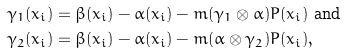<formula> <loc_0><loc_0><loc_500><loc_500>& \gamma _ { 1 } ( x _ { i } ) = \beta ( x _ { i } ) - \alpha ( x _ { i } ) - m ( \gamma _ { 1 } \otimes \alpha ) P ( x _ { i } ) \ \text {and} \\ & \gamma _ { 2 } ( x _ { i } ) = \beta ( x _ { i } ) - \alpha ( x _ { i } ) - m ( \alpha \otimes \gamma _ { 2 } ) P ( x _ { i } ) ,</formula> 